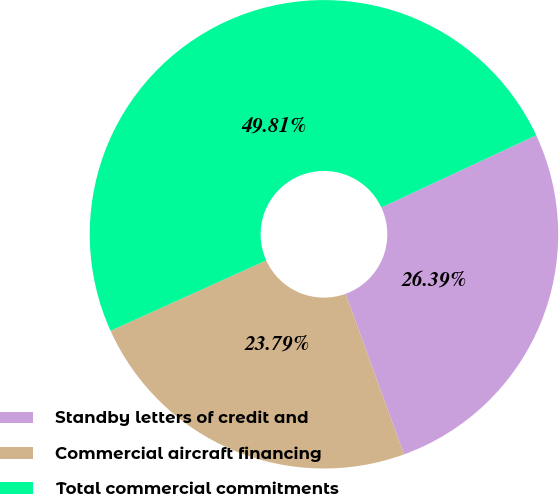Convert chart. <chart><loc_0><loc_0><loc_500><loc_500><pie_chart><fcel>Standby letters of credit and<fcel>Commercial aircraft financing<fcel>Total commercial commitments<nl><fcel>26.39%<fcel>23.79%<fcel>49.81%<nl></chart> 